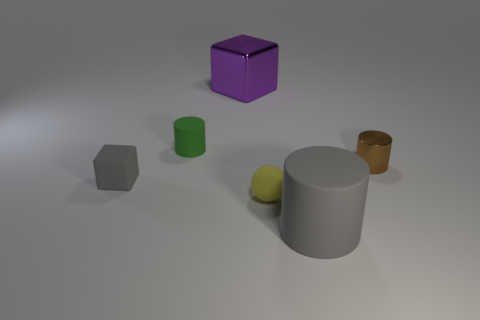Add 4 big cyan metallic objects. How many objects exist? 10 Subtract all spheres. How many objects are left? 5 Add 3 tiny matte cylinders. How many tiny matte cylinders exist? 4 Subtract 0 gray spheres. How many objects are left? 6 Subtract all brown metallic cubes. Subtract all large gray things. How many objects are left? 5 Add 4 brown metal objects. How many brown metal objects are left? 5 